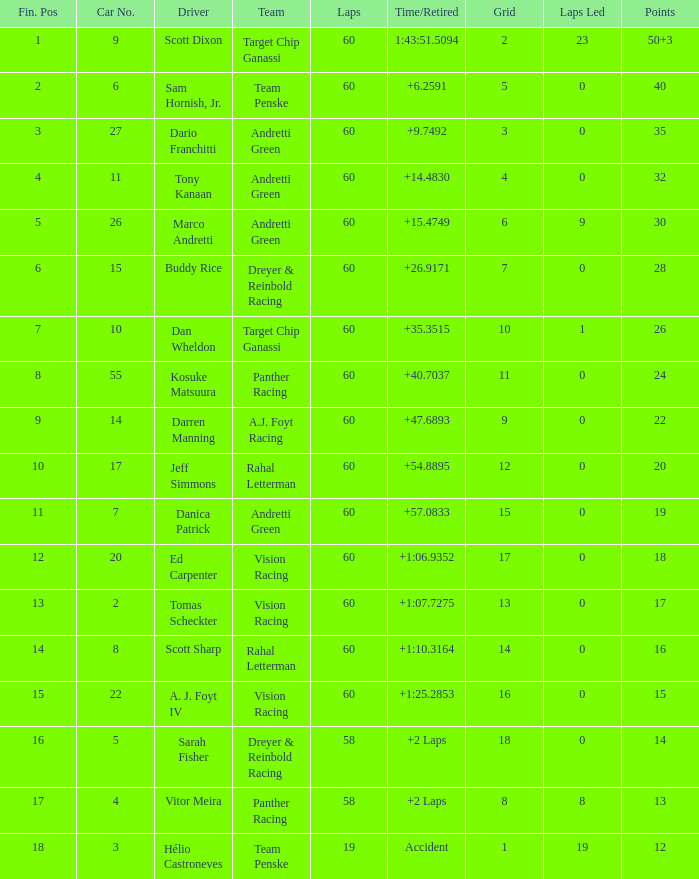What is the team associated with scott dixon? Target Chip Ganassi. 